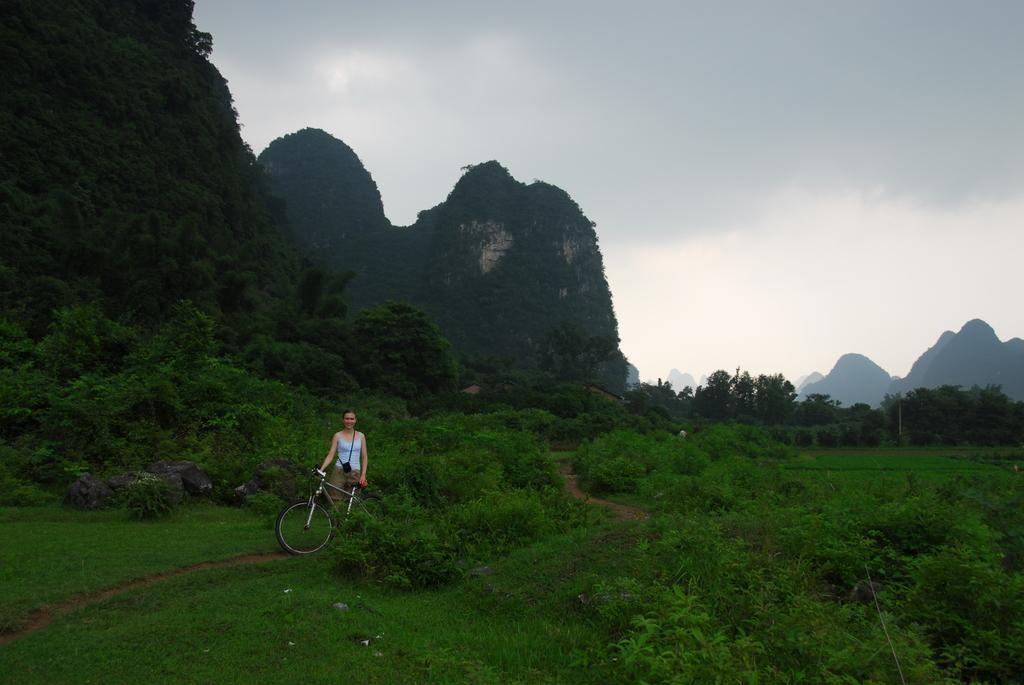Who is the main subject in the image? There is a lady in the image. What is the lady holding in the image? The lady is holding a cycle. What can be seen on the ground in the image? There are plants, trees, and rocks on the ground. What is visible in the background of the image? There are hills and the sky in the background. What can be observed in the sky in the image? Clouds are present in the sky. What is the price of the ghost in the image? There is no ghost present in the image, so it is not possible to determine its price. 